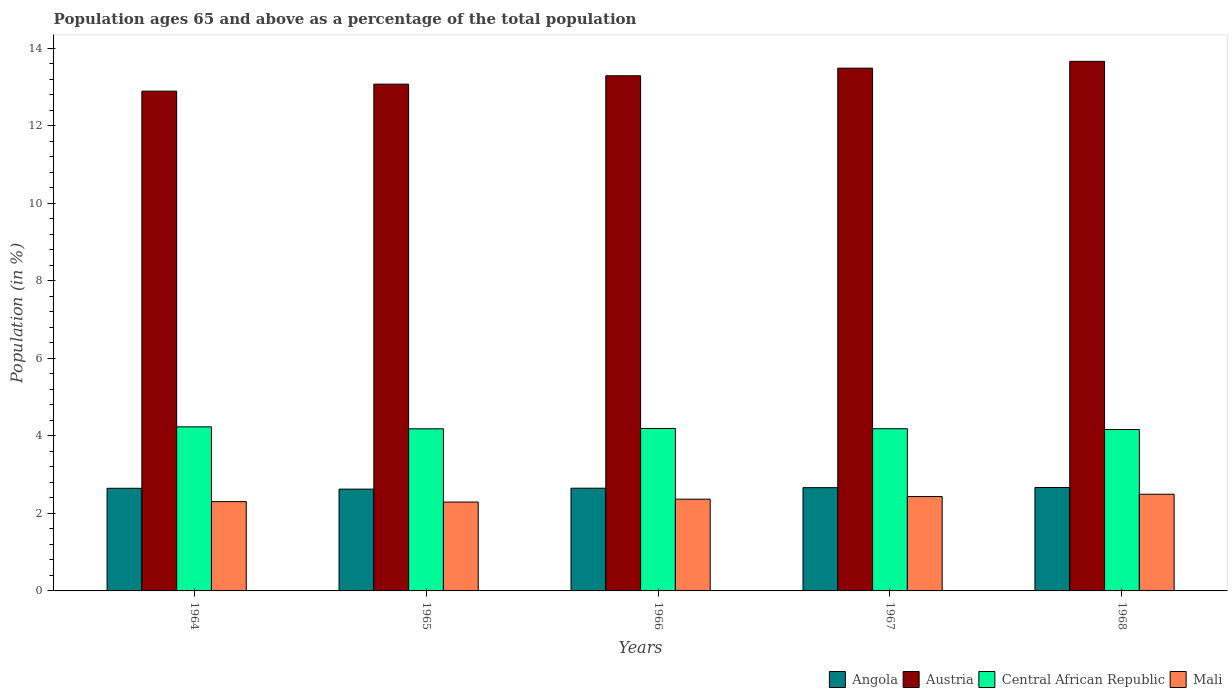How many different coloured bars are there?
Provide a short and direct response. 4. Are the number of bars per tick equal to the number of legend labels?
Offer a terse response. Yes. Are the number of bars on each tick of the X-axis equal?
Offer a terse response. Yes. How many bars are there on the 4th tick from the left?
Give a very brief answer. 4. What is the label of the 3rd group of bars from the left?
Offer a terse response. 1966. In how many cases, is the number of bars for a given year not equal to the number of legend labels?
Keep it short and to the point. 0. What is the percentage of the population ages 65 and above in Mali in 1968?
Offer a very short reply. 2.5. Across all years, what is the maximum percentage of the population ages 65 and above in Austria?
Provide a succinct answer. 13.67. Across all years, what is the minimum percentage of the population ages 65 and above in Angola?
Your answer should be compact. 2.63. In which year was the percentage of the population ages 65 and above in Angola maximum?
Offer a very short reply. 1968. In which year was the percentage of the population ages 65 and above in Austria minimum?
Your response must be concise. 1964. What is the total percentage of the population ages 65 and above in Angola in the graph?
Make the answer very short. 13.26. What is the difference between the percentage of the population ages 65 and above in Austria in 1966 and that in 1968?
Ensure brevity in your answer.  -0.37. What is the difference between the percentage of the population ages 65 and above in Austria in 1968 and the percentage of the population ages 65 and above in Central African Republic in 1967?
Provide a short and direct response. 9.48. What is the average percentage of the population ages 65 and above in Central African Republic per year?
Offer a very short reply. 4.19. In the year 1966, what is the difference between the percentage of the population ages 65 and above in Central African Republic and percentage of the population ages 65 and above in Mali?
Give a very brief answer. 1.83. What is the ratio of the percentage of the population ages 65 and above in Mali in 1966 to that in 1968?
Offer a very short reply. 0.95. Is the percentage of the population ages 65 and above in Austria in 1964 less than that in 1967?
Provide a succinct answer. Yes. What is the difference between the highest and the second highest percentage of the population ages 65 and above in Angola?
Provide a succinct answer. 0. What is the difference between the highest and the lowest percentage of the population ages 65 and above in Mali?
Make the answer very short. 0.2. Is the sum of the percentage of the population ages 65 and above in Central African Republic in 1964 and 1967 greater than the maximum percentage of the population ages 65 and above in Mali across all years?
Ensure brevity in your answer.  Yes. What does the 2nd bar from the left in 1964 represents?
Give a very brief answer. Austria. What does the 3rd bar from the right in 1967 represents?
Your answer should be very brief. Austria. Are all the bars in the graph horizontal?
Make the answer very short. No. Are the values on the major ticks of Y-axis written in scientific E-notation?
Your answer should be very brief. No. Does the graph contain any zero values?
Make the answer very short. No. How many legend labels are there?
Ensure brevity in your answer.  4. How are the legend labels stacked?
Give a very brief answer. Horizontal. What is the title of the graph?
Your answer should be compact. Population ages 65 and above as a percentage of the total population. Does "Fiji" appear as one of the legend labels in the graph?
Give a very brief answer. No. What is the Population (in %) in Angola in 1964?
Your response must be concise. 2.65. What is the Population (in %) of Austria in 1964?
Give a very brief answer. 12.9. What is the Population (in %) in Central African Republic in 1964?
Make the answer very short. 4.24. What is the Population (in %) in Mali in 1964?
Provide a short and direct response. 2.3. What is the Population (in %) in Angola in 1965?
Provide a short and direct response. 2.63. What is the Population (in %) of Austria in 1965?
Offer a terse response. 13.08. What is the Population (in %) of Central African Republic in 1965?
Keep it short and to the point. 4.18. What is the Population (in %) of Mali in 1965?
Offer a terse response. 2.29. What is the Population (in %) in Angola in 1966?
Offer a very short reply. 2.65. What is the Population (in %) of Austria in 1966?
Offer a terse response. 13.3. What is the Population (in %) in Central African Republic in 1966?
Provide a short and direct response. 4.19. What is the Population (in %) of Mali in 1966?
Give a very brief answer. 2.37. What is the Population (in %) of Angola in 1967?
Ensure brevity in your answer.  2.67. What is the Population (in %) in Austria in 1967?
Ensure brevity in your answer.  13.49. What is the Population (in %) in Central African Republic in 1967?
Your answer should be very brief. 4.19. What is the Population (in %) in Mali in 1967?
Your answer should be very brief. 2.44. What is the Population (in %) in Angola in 1968?
Give a very brief answer. 2.67. What is the Population (in %) in Austria in 1968?
Your response must be concise. 13.67. What is the Population (in %) in Central African Republic in 1968?
Give a very brief answer. 4.17. What is the Population (in %) in Mali in 1968?
Keep it short and to the point. 2.5. Across all years, what is the maximum Population (in %) of Angola?
Give a very brief answer. 2.67. Across all years, what is the maximum Population (in %) of Austria?
Provide a short and direct response. 13.67. Across all years, what is the maximum Population (in %) in Central African Republic?
Ensure brevity in your answer.  4.24. Across all years, what is the maximum Population (in %) of Mali?
Keep it short and to the point. 2.5. Across all years, what is the minimum Population (in %) in Angola?
Provide a short and direct response. 2.63. Across all years, what is the minimum Population (in %) of Austria?
Keep it short and to the point. 12.9. Across all years, what is the minimum Population (in %) in Central African Republic?
Your answer should be very brief. 4.17. Across all years, what is the minimum Population (in %) of Mali?
Offer a terse response. 2.29. What is the total Population (in %) of Angola in the graph?
Give a very brief answer. 13.26. What is the total Population (in %) in Austria in the graph?
Offer a terse response. 66.43. What is the total Population (in %) of Central African Republic in the graph?
Provide a short and direct response. 20.96. What is the total Population (in %) in Mali in the graph?
Keep it short and to the point. 11.9. What is the difference between the Population (in %) of Angola in 1964 and that in 1965?
Keep it short and to the point. 0.02. What is the difference between the Population (in %) in Austria in 1964 and that in 1965?
Provide a succinct answer. -0.18. What is the difference between the Population (in %) in Central African Republic in 1964 and that in 1965?
Your answer should be compact. 0.05. What is the difference between the Population (in %) of Mali in 1964 and that in 1965?
Make the answer very short. 0.01. What is the difference between the Population (in %) of Angola in 1964 and that in 1966?
Offer a terse response. -0. What is the difference between the Population (in %) of Austria in 1964 and that in 1966?
Your answer should be very brief. -0.4. What is the difference between the Population (in %) in Central African Republic in 1964 and that in 1966?
Offer a terse response. 0.04. What is the difference between the Population (in %) in Mali in 1964 and that in 1966?
Give a very brief answer. -0.06. What is the difference between the Population (in %) of Angola in 1964 and that in 1967?
Offer a terse response. -0.02. What is the difference between the Population (in %) in Austria in 1964 and that in 1967?
Give a very brief answer. -0.59. What is the difference between the Population (in %) of Central African Republic in 1964 and that in 1967?
Your response must be concise. 0.05. What is the difference between the Population (in %) of Mali in 1964 and that in 1967?
Your answer should be very brief. -0.13. What is the difference between the Population (in %) in Angola in 1964 and that in 1968?
Offer a terse response. -0.02. What is the difference between the Population (in %) of Austria in 1964 and that in 1968?
Ensure brevity in your answer.  -0.77. What is the difference between the Population (in %) of Central African Republic in 1964 and that in 1968?
Keep it short and to the point. 0.07. What is the difference between the Population (in %) in Mali in 1964 and that in 1968?
Offer a very short reply. -0.19. What is the difference between the Population (in %) in Angola in 1965 and that in 1966?
Provide a short and direct response. -0.02. What is the difference between the Population (in %) in Austria in 1965 and that in 1966?
Your response must be concise. -0.22. What is the difference between the Population (in %) in Central African Republic in 1965 and that in 1966?
Make the answer very short. -0.01. What is the difference between the Population (in %) in Mali in 1965 and that in 1966?
Offer a terse response. -0.07. What is the difference between the Population (in %) of Angola in 1965 and that in 1967?
Offer a terse response. -0.04. What is the difference between the Population (in %) in Austria in 1965 and that in 1967?
Your answer should be very brief. -0.41. What is the difference between the Population (in %) of Central African Republic in 1965 and that in 1967?
Provide a succinct answer. -0. What is the difference between the Population (in %) of Mali in 1965 and that in 1967?
Ensure brevity in your answer.  -0.14. What is the difference between the Population (in %) of Angola in 1965 and that in 1968?
Provide a short and direct response. -0.04. What is the difference between the Population (in %) of Austria in 1965 and that in 1968?
Your answer should be compact. -0.59. What is the difference between the Population (in %) in Central African Republic in 1965 and that in 1968?
Your response must be concise. 0.02. What is the difference between the Population (in %) of Mali in 1965 and that in 1968?
Your answer should be very brief. -0.2. What is the difference between the Population (in %) in Angola in 1966 and that in 1967?
Make the answer very short. -0.01. What is the difference between the Population (in %) of Austria in 1966 and that in 1967?
Make the answer very short. -0.2. What is the difference between the Population (in %) of Central African Republic in 1966 and that in 1967?
Ensure brevity in your answer.  0.01. What is the difference between the Population (in %) in Mali in 1966 and that in 1967?
Offer a very short reply. -0.07. What is the difference between the Population (in %) in Angola in 1966 and that in 1968?
Provide a short and direct response. -0.02. What is the difference between the Population (in %) of Austria in 1966 and that in 1968?
Your answer should be compact. -0.37. What is the difference between the Population (in %) of Central African Republic in 1966 and that in 1968?
Give a very brief answer. 0.03. What is the difference between the Population (in %) in Mali in 1966 and that in 1968?
Provide a succinct answer. -0.13. What is the difference between the Population (in %) of Angola in 1967 and that in 1968?
Offer a terse response. -0. What is the difference between the Population (in %) in Austria in 1967 and that in 1968?
Your answer should be very brief. -0.18. What is the difference between the Population (in %) in Mali in 1967 and that in 1968?
Your answer should be very brief. -0.06. What is the difference between the Population (in %) of Angola in 1964 and the Population (in %) of Austria in 1965?
Offer a very short reply. -10.43. What is the difference between the Population (in %) of Angola in 1964 and the Population (in %) of Central African Republic in 1965?
Your answer should be very brief. -1.53. What is the difference between the Population (in %) in Angola in 1964 and the Population (in %) in Mali in 1965?
Ensure brevity in your answer.  0.36. What is the difference between the Population (in %) in Austria in 1964 and the Population (in %) in Central African Republic in 1965?
Offer a very short reply. 8.71. What is the difference between the Population (in %) in Austria in 1964 and the Population (in %) in Mali in 1965?
Provide a short and direct response. 10.61. What is the difference between the Population (in %) in Central African Republic in 1964 and the Population (in %) in Mali in 1965?
Offer a terse response. 1.94. What is the difference between the Population (in %) of Angola in 1964 and the Population (in %) of Austria in 1966?
Provide a short and direct response. -10.65. What is the difference between the Population (in %) of Angola in 1964 and the Population (in %) of Central African Republic in 1966?
Ensure brevity in your answer.  -1.54. What is the difference between the Population (in %) in Angola in 1964 and the Population (in %) in Mali in 1966?
Your answer should be compact. 0.28. What is the difference between the Population (in %) in Austria in 1964 and the Population (in %) in Central African Republic in 1966?
Your answer should be compact. 8.71. What is the difference between the Population (in %) of Austria in 1964 and the Population (in %) of Mali in 1966?
Keep it short and to the point. 10.53. What is the difference between the Population (in %) in Central African Republic in 1964 and the Population (in %) in Mali in 1966?
Make the answer very short. 1.87. What is the difference between the Population (in %) of Angola in 1964 and the Population (in %) of Austria in 1967?
Offer a very short reply. -10.84. What is the difference between the Population (in %) of Angola in 1964 and the Population (in %) of Central African Republic in 1967?
Ensure brevity in your answer.  -1.54. What is the difference between the Population (in %) in Angola in 1964 and the Population (in %) in Mali in 1967?
Offer a very short reply. 0.21. What is the difference between the Population (in %) of Austria in 1964 and the Population (in %) of Central African Republic in 1967?
Ensure brevity in your answer.  8.71. What is the difference between the Population (in %) in Austria in 1964 and the Population (in %) in Mali in 1967?
Provide a succinct answer. 10.46. What is the difference between the Population (in %) in Central African Republic in 1964 and the Population (in %) in Mali in 1967?
Your answer should be very brief. 1.8. What is the difference between the Population (in %) in Angola in 1964 and the Population (in %) in Austria in 1968?
Offer a very short reply. -11.02. What is the difference between the Population (in %) in Angola in 1964 and the Population (in %) in Central African Republic in 1968?
Your response must be concise. -1.52. What is the difference between the Population (in %) in Angola in 1964 and the Population (in %) in Mali in 1968?
Offer a very short reply. 0.15. What is the difference between the Population (in %) in Austria in 1964 and the Population (in %) in Central African Republic in 1968?
Your answer should be compact. 8.73. What is the difference between the Population (in %) in Austria in 1964 and the Population (in %) in Mali in 1968?
Offer a very short reply. 10.4. What is the difference between the Population (in %) of Central African Republic in 1964 and the Population (in %) of Mali in 1968?
Ensure brevity in your answer.  1.74. What is the difference between the Population (in %) of Angola in 1965 and the Population (in %) of Austria in 1966?
Offer a terse response. -10.67. What is the difference between the Population (in %) of Angola in 1965 and the Population (in %) of Central African Republic in 1966?
Provide a succinct answer. -1.57. What is the difference between the Population (in %) in Angola in 1965 and the Population (in %) in Mali in 1966?
Make the answer very short. 0.26. What is the difference between the Population (in %) of Austria in 1965 and the Population (in %) of Central African Republic in 1966?
Your response must be concise. 8.89. What is the difference between the Population (in %) of Austria in 1965 and the Population (in %) of Mali in 1966?
Ensure brevity in your answer.  10.71. What is the difference between the Population (in %) in Central African Republic in 1965 and the Population (in %) in Mali in 1966?
Keep it short and to the point. 1.82. What is the difference between the Population (in %) in Angola in 1965 and the Population (in %) in Austria in 1967?
Your answer should be very brief. -10.87. What is the difference between the Population (in %) of Angola in 1965 and the Population (in %) of Central African Republic in 1967?
Offer a terse response. -1.56. What is the difference between the Population (in %) in Angola in 1965 and the Population (in %) in Mali in 1967?
Your answer should be very brief. 0.19. What is the difference between the Population (in %) in Austria in 1965 and the Population (in %) in Central African Republic in 1967?
Provide a short and direct response. 8.89. What is the difference between the Population (in %) in Austria in 1965 and the Population (in %) in Mali in 1967?
Give a very brief answer. 10.64. What is the difference between the Population (in %) in Central African Republic in 1965 and the Population (in %) in Mali in 1967?
Make the answer very short. 1.75. What is the difference between the Population (in %) of Angola in 1965 and the Population (in %) of Austria in 1968?
Give a very brief answer. -11.04. What is the difference between the Population (in %) of Angola in 1965 and the Population (in %) of Central African Republic in 1968?
Give a very brief answer. -1.54. What is the difference between the Population (in %) in Angola in 1965 and the Population (in %) in Mali in 1968?
Give a very brief answer. 0.13. What is the difference between the Population (in %) in Austria in 1965 and the Population (in %) in Central African Republic in 1968?
Keep it short and to the point. 8.91. What is the difference between the Population (in %) in Austria in 1965 and the Population (in %) in Mali in 1968?
Offer a terse response. 10.58. What is the difference between the Population (in %) of Central African Republic in 1965 and the Population (in %) of Mali in 1968?
Provide a succinct answer. 1.69. What is the difference between the Population (in %) in Angola in 1966 and the Population (in %) in Austria in 1967?
Your response must be concise. -10.84. What is the difference between the Population (in %) in Angola in 1966 and the Population (in %) in Central African Republic in 1967?
Offer a very short reply. -1.54. What is the difference between the Population (in %) of Angola in 1966 and the Population (in %) of Mali in 1967?
Your answer should be compact. 0.21. What is the difference between the Population (in %) in Austria in 1966 and the Population (in %) in Central African Republic in 1967?
Your response must be concise. 9.11. What is the difference between the Population (in %) in Austria in 1966 and the Population (in %) in Mali in 1967?
Ensure brevity in your answer.  10.86. What is the difference between the Population (in %) in Central African Republic in 1966 and the Population (in %) in Mali in 1967?
Make the answer very short. 1.76. What is the difference between the Population (in %) of Angola in 1966 and the Population (in %) of Austria in 1968?
Your answer should be very brief. -11.02. What is the difference between the Population (in %) in Angola in 1966 and the Population (in %) in Central African Republic in 1968?
Offer a very short reply. -1.52. What is the difference between the Population (in %) of Angola in 1966 and the Population (in %) of Mali in 1968?
Keep it short and to the point. 0.16. What is the difference between the Population (in %) in Austria in 1966 and the Population (in %) in Central African Republic in 1968?
Your answer should be very brief. 9.13. What is the difference between the Population (in %) in Austria in 1966 and the Population (in %) in Mali in 1968?
Offer a very short reply. 10.8. What is the difference between the Population (in %) in Central African Republic in 1966 and the Population (in %) in Mali in 1968?
Your answer should be very brief. 1.7. What is the difference between the Population (in %) in Angola in 1967 and the Population (in %) in Austria in 1968?
Your answer should be compact. -11. What is the difference between the Population (in %) in Angola in 1967 and the Population (in %) in Central African Republic in 1968?
Offer a very short reply. -1.5. What is the difference between the Population (in %) of Angola in 1967 and the Population (in %) of Mali in 1968?
Make the answer very short. 0.17. What is the difference between the Population (in %) of Austria in 1967 and the Population (in %) of Central African Republic in 1968?
Provide a succinct answer. 9.33. What is the difference between the Population (in %) in Austria in 1967 and the Population (in %) in Mali in 1968?
Make the answer very short. 11. What is the difference between the Population (in %) in Central African Republic in 1967 and the Population (in %) in Mali in 1968?
Your response must be concise. 1.69. What is the average Population (in %) of Angola per year?
Offer a terse response. 2.65. What is the average Population (in %) in Austria per year?
Your response must be concise. 13.29. What is the average Population (in %) of Central African Republic per year?
Offer a terse response. 4.19. What is the average Population (in %) in Mali per year?
Provide a short and direct response. 2.38. In the year 1964, what is the difference between the Population (in %) in Angola and Population (in %) in Austria?
Offer a terse response. -10.25. In the year 1964, what is the difference between the Population (in %) of Angola and Population (in %) of Central African Republic?
Make the answer very short. -1.59. In the year 1964, what is the difference between the Population (in %) in Angola and Population (in %) in Mali?
Your response must be concise. 0.34. In the year 1964, what is the difference between the Population (in %) in Austria and Population (in %) in Central African Republic?
Make the answer very short. 8.66. In the year 1964, what is the difference between the Population (in %) in Austria and Population (in %) in Mali?
Provide a short and direct response. 10.59. In the year 1964, what is the difference between the Population (in %) in Central African Republic and Population (in %) in Mali?
Your response must be concise. 1.93. In the year 1965, what is the difference between the Population (in %) of Angola and Population (in %) of Austria?
Provide a short and direct response. -10.45. In the year 1965, what is the difference between the Population (in %) of Angola and Population (in %) of Central African Republic?
Your answer should be very brief. -1.56. In the year 1965, what is the difference between the Population (in %) of Angola and Population (in %) of Mali?
Keep it short and to the point. 0.33. In the year 1965, what is the difference between the Population (in %) in Austria and Population (in %) in Central African Republic?
Your answer should be compact. 8.9. In the year 1965, what is the difference between the Population (in %) of Austria and Population (in %) of Mali?
Offer a terse response. 10.79. In the year 1965, what is the difference between the Population (in %) of Central African Republic and Population (in %) of Mali?
Your answer should be very brief. 1.89. In the year 1966, what is the difference between the Population (in %) in Angola and Population (in %) in Austria?
Make the answer very short. -10.65. In the year 1966, what is the difference between the Population (in %) of Angola and Population (in %) of Central African Republic?
Provide a short and direct response. -1.54. In the year 1966, what is the difference between the Population (in %) of Angola and Population (in %) of Mali?
Provide a short and direct response. 0.28. In the year 1966, what is the difference between the Population (in %) of Austria and Population (in %) of Central African Republic?
Your response must be concise. 9.1. In the year 1966, what is the difference between the Population (in %) of Austria and Population (in %) of Mali?
Keep it short and to the point. 10.93. In the year 1966, what is the difference between the Population (in %) in Central African Republic and Population (in %) in Mali?
Your answer should be very brief. 1.83. In the year 1967, what is the difference between the Population (in %) in Angola and Population (in %) in Austria?
Provide a short and direct response. -10.83. In the year 1967, what is the difference between the Population (in %) in Angola and Population (in %) in Central African Republic?
Offer a very short reply. -1.52. In the year 1967, what is the difference between the Population (in %) in Angola and Population (in %) in Mali?
Keep it short and to the point. 0.23. In the year 1967, what is the difference between the Population (in %) of Austria and Population (in %) of Central African Republic?
Ensure brevity in your answer.  9.31. In the year 1967, what is the difference between the Population (in %) in Austria and Population (in %) in Mali?
Provide a succinct answer. 11.06. In the year 1967, what is the difference between the Population (in %) of Central African Republic and Population (in %) of Mali?
Your answer should be compact. 1.75. In the year 1968, what is the difference between the Population (in %) of Angola and Population (in %) of Austria?
Your response must be concise. -11. In the year 1968, what is the difference between the Population (in %) in Angola and Population (in %) in Central African Republic?
Provide a succinct answer. -1.5. In the year 1968, what is the difference between the Population (in %) in Angola and Population (in %) in Mali?
Provide a short and direct response. 0.17. In the year 1968, what is the difference between the Population (in %) in Austria and Population (in %) in Central African Republic?
Your answer should be compact. 9.5. In the year 1968, what is the difference between the Population (in %) of Austria and Population (in %) of Mali?
Your answer should be compact. 11.17. In the year 1968, what is the difference between the Population (in %) in Central African Republic and Population (in %) in Mali?
Provide a short and direct response. 1.67. What is the ratio of the Population (in %) of Angola in 1964 to that in 1965?
Ensure brevity in your answer.  1.01. What is the ratio of the Population (in %) of Austria in 1964 to that in 1965?
Your answer should be very brief. 0.99. What is the ratio of the Population (in %) in Central African Republic in 1964 to that in 1965?
Ensure brevity in your answer.  1.01. What is the ratio of the Population (in %) in Angola in 1964 to that in 1966?
Your answer should be compact. 1. What is the ratio of the Population (in %) of Austria in 1964 to that in 1966?
Offer a very short reply. 0.97. What is the ratio of the Population (in %) in Central African Republic in 1964 to that in 1966?
Your response must be concise. 1.01. What is the ratio of the Population (in %) in Mali in 1964 to that in 1966?
Offer a very short reply. 0.97. What is the ratio of the Population (in %) in Angola in 1964 to that in 1967?
Provide a short and direct response. 0.99. What is the ratio of the Population (in %) in Austria in 1964 to that in 1967?
Your response must be concise. 0.96. What is the ratio of the Population (in %) of Central African Republic in 1964 to that in 1967?
Provide a succinct answer. 1.01. What is the ratio of the Population (in %) in Mali in 1964 to that in 1967?
Your answer should be very brief. 0.95. What is the ratio of the Population (in %) of Angola in 1964 to that in 1968?
Make the answer very short. 0.99. What is the ratio of the Population (in %) of Austria in 1964 to that in 1968?
Ensure brevity in your answer.  0.94. What is the ratio of the Population (in %) of Central African Republic in 1964 to that in 1968?
Provide a short and direct response. 1.02. What is the ratio of the Population (in %) of Mali in 1964 to that in 1968?
Offer a very short reply. 0.92. What is the ratio of the Population (in %) in Angola in 1965 to that in 1966?
Offer a very short reply. 0.99. What is the ratio of the Population (in %) in Austria in 1965 to that in 1966?
Give a very brief answer. 0.98. What is the ratio of the Population (in %) in Mali in 1965 to that in 1966?
Offer a terse response. 0.97. What is the ratio of the Population (in %) of Angola in 1965 to that in 1967?
Offer a terse response. 0.99. What is the ratio of the Population (in %) in Austria in 1965 to that in 1967?
Give a very brief answer. 0.97. What is the ratio of the Population (in %) in Central African Republic in 1965 to that in 1967?
Offer a terse response. 1. What is the ratio of the Population (in %) in Mali in 1965 to that in 1967?
Your answer should be very brief. 0.94. What is the ratio of the Population (in %) in Mali in 1965 to that in 1968?
Ensure brevity in your answer.  0.92. What is the ratio of the Population (in %) in Austria in 1966 to that in 1967?
Offer a terse response. 0.99. What is the ratio of the Population (in %) of Central African Republic in 1966 to that in 1967?
Offer a very short reply. 1. What is the ratio of the Population (in %) of Mali in 1966 to that in 1967?
Keep it short and to the point. 0.97. What is the ratio of the Population (in %) of Angola in 1966 to that in 1968?
Offer a terse response. 0.99. What is the ratio of the Population (in %) of Austria in 1966 to that in 1968?
Provide a short and direct response. 0.97. What is the ratio of the Population (in %) of Central African Republic in 1966 to that in 1968?
Offer a terse response. 1.01. What is the ratio of the Population (in %) of Mali in 1966 to that in 1968?
Give a very brief answer. 0.95. What is the ratio of the Population (in %) of Angola in 1967 to that in 1968?
Keep it short and to the point. 1. What is the ratio of the Population (in %) of Austria in 1967 to that in 1968?
Provide a succinct answer. 0.99. What is the ratio of the Population (in %) of Mali in 1967 to that in 1968?
Offer a terse response. 0.98. What is the difference between the highest and the second highest Population (in %) in Angola?
Make the answer very short. 0. What is the difference between the highest and the second highest Population (in %) of Austria?
Ensure brevity in your answer.  0.18. What is the difference between the highest and the second highest Population (in %) of Central African Republic?
Give a very brief answer. 0.04. What is the difference between the highest and the second highest Population (in %) in Mali?
Your answer should be compact. 0.06. What is the difference between the highest and the lowest Population (in %) of Angola?
Provide a succinct answer. 0.04. What is the difference between the highest and the lowest Population (in %) in Austria?
Offer a terse response. 0.77. What is the difference between the highest and the lowest Population (in %) in Central African Republic?
Your answer should be compact. 0.07. What is the difference between the highest and the lowest Population (in %) in Mali?
Your response must be concise. 0.2. 